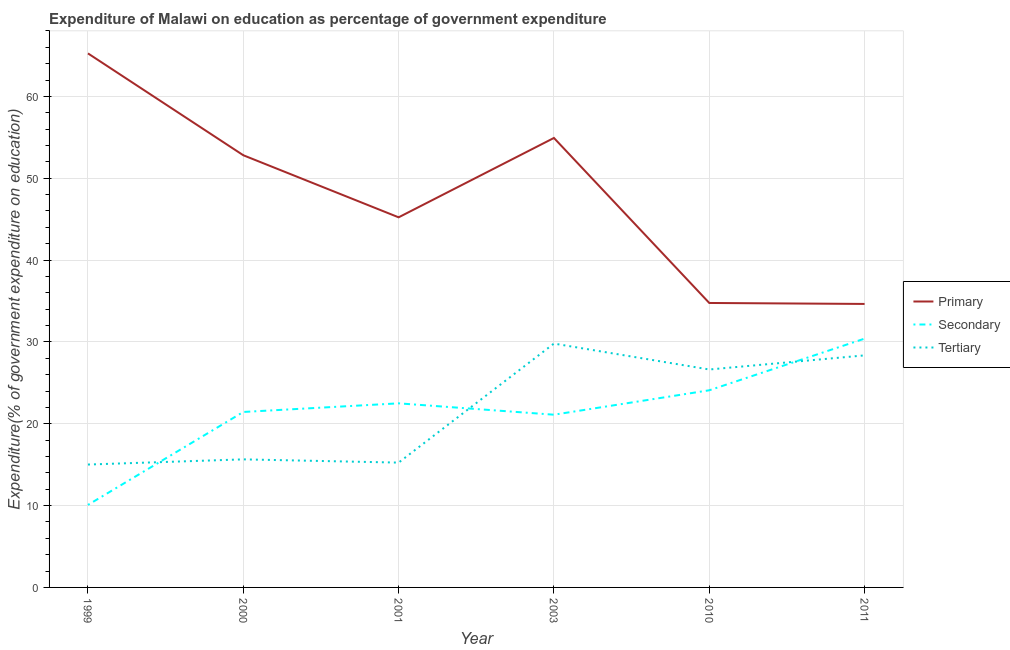Is the number of lines equal to the number of legend labels?
Your answer should be compact. Yes. What is the expenditure on tertiary education in 2000?
Offer a very short reply. 15.65. Across all years, what is the maximum expenditure on primary education?
Provide a short and direct response. 65.26. Across all years, what is the minimum expenditure on secondary education?
Provide a short and direct response. 10.08. In which year was the expenditure on secondary education maximum?
Your answer should be compact. 2011. What is the total expenditure on primary education in the graph?
Your answer should be compact. 287.62. What is the difference between the expenditure on tertiary education in 2000 and that in 2003?
Your answer should be very brief. -14.15. What is the difference between the expenditure on tertiary education in 2011 and the expenditure on secondary education in 2000?
Offer a very short reply. 6.92. What is the average expenditure on secondary education per year?
Provide a succinct answer. 21.6. In the year 2003, what is the difference between the expenditure on tertiary education and expenditure on primary education?
Make the answer very short. -25.13. What is the ratio of the expenditure on secondary education in 2010 to that in 2011?
Give a very brief answer. 0.79. Is the expenditure on tertiary education in 1999 less than that in 2001?
Provide a succinct answer. Yes. What is the difference between the highest and the second highest expenditure on tertiary education?
Your answer should be very brief. 1.44. What is the difference between the highest and the lowest expenditure on secondary education?
Offer a very short reply. 20.32. In how many years, is the expenditure on tertiary education greater than the average expenditure on tertiary education taken over all years?
Your response must be concise. 3. Is the sum of the expenditure on primary education in 2001 and 2010 greater than the maximum expenditure on tertiary education across all years?
Make the answer very short. Yes. Is the expenditure on primary education strictly greater than the expenditure on tertiary education over the years?
Offer a very short reply. Yes. Is the expenditure on secondary education strictly less than the expenditure on primary education over the years?
Your answer should be very brief. Yes. How many lines are there?
Give a very brief answer. 3. How many years are there in the graph?
Offer a terse response. 6. Are the values on the major ticks of Y-axis written in scientific E-notation?
Provide a succinct answer. No. Does the graph contain any zero values?
Make the answer very short. No. Does the graph contain grids?
Ensure brevity in your answer.  Yes. Where does the legend appear in the graph?
Make the answer very short. Center right. How many legend labels are there?
Keep it short and to the point. 3. What is the title of the graph?
Provide a succinct answer. Expenditure of Malawi on education as percentage of government expenditure. What is the label or title of the X-axis?
Offer a terse response. Year. What is the label or title of the Y-axis?
Make the answer very short. Expenditure(% of government expenditure on education). What is the Expenditure(% of government expenditure on education) of Primary in 1999?
Your answer should be very brief. 65.26. What is the Expenditure(% of government expenditure on education) of Secondary in 1999?
Provide a short and direct response. 10.08. What is the Expenditure(% of government expenditure on education) in Tertiary in 1999?
Your answer should be very brief. 15.02. What is the Expenditure(% of government expenditure on education) in Primary in 2000?
Offer a very short reply. 52.81. What is the Expenditure(% of government expenditure on education) in Secondary in 2000?
Keep it short and to the point. 21.44. What is the Expenditure(% of government expenditure on education) in Tertiary in 2000?
Keep it short and to the point. 15.65. What is the Expenditure(% of government expenditure on education) in Primary in 2001?
Offer a very short reply. 45.23. What is the Expenditure(% of government expenditure on education) of Secondary in 2001?
Provide a succinct answer. 22.5. What is the Expenditure(% of government expenditure on education) in Tertiary in 2001?
Provide a short and direct response. 15.25. What is the Expenditure(% of government expenditure on education) of Primary in 2003?
Provide a succinct answer. 54.92. What is the Expenditure(% of government expenditure on education) of Secondary in 2003?
Offer a terse response. 21.11. What is the Expenditure(% of government expenditure on education) of Tertiary in 2003?
Make the answer very short. 29.8. What is the Expenditure(% of government expenditure on education) in Primary in 2010?
Keep it short and to the point. 34.76. What is the Expenditure(% of government expenditure on education) of Secondary in 2010?
Offer a very short reply. 24.09. What is the Expenditure(% of government expenditure on education) in Tertiary in 2010?
Provide a succinct answer. 26.63. What is the Expenditure(% of government expenditure on education) in Primary in 2011?
Your answer should be very brief. 34.64. What is the Expenditure(% of government expenditure on education) in Secondary in 2011?
Offer a terse response. 30.4. What is the Expenditure(% of government expenditure on education) in Tertiary in 2011?
Your answer should be very brief. 28.36. Across all years, what is the maximum Expenditure(% of government expenditure on education) in Primary?
Offer a terse response. 65.26. Across all years, what is the maximum Expenditure(% of government expenditure on education) of Secondary?
Your response must be concise. 30.4. Across all years, what is the maximum Expenditure(% of government expenditure on education) of Tertiary?
Keep it short and to the point. 29.8. Across all years, what is the minimum Expenditure(% of government expenditure on education) in Primary?
Provide a succinct answer. 34.64. Across all years, what is the minimum Expenditure(% of government expenditure on education) in Secondary?
Offer a very short reply. 10.08. Across all years, what is the minimum Expenditure(% of government expenditure on education) in Tertiary?
Your response must be concise. 15.02. What is the total Expenditure(% of government expenditure on education) in Primary in the graph?
Your answer should be very brief. 287.62. What is the total Expenditure(% of government expenditure on education) in Secondary in the graph?
Your answer should be very brief. 129.62. What is the total Expenditure(% of government expenditure on education) in Tertiary in the graph?
Provide a short and direct response. 130.7. What is the difference between the Expenditure(% of government expenditure on education) of Primary in 1999 and that in 2000?
Offer a very short reply. 12.44. What is the difference between the Expenditure(% of government expenditure on education) of Secondary in 1999 and that in 2000?
Your answer should be compact. -11.36. What is the difference between the Expenditure(% of government expenditure on education) in Tertiary in 1999 and that in 2000?
Provide a succinct answer. -0.63. What is the difference between the Expenditure(% of government expenditure on education) in Primary in 1999 and that in 2001?
Offer a very short reply. 20.03. What is the difference between the Expenditure(% of government expenditure on education) in Secondary in 1999 and that in 2001?
Provide a short and direct response. -12.41. What is the difference between the Expenditure(% of government expenditure on education) in Tertiary in 1999 and that in 2001?
Keep it short and to the point. -0.24. What is the difference between the Expenditure(% of government expenditure on education) in Primary in 1999 and that in 2003?
Ensure brevity in your answer.  10.33. What is the difference between the Expenditure(% of government expenditure on education) of Secondary in 1999 and that in 2003?
Provide a short and direct response. -11.02. What is the difference between the Expenditure(% of government expenditure on education) of Tertiary in 1999 and that in 2003?
Make the answer very short. -14.78. What is the difference between the Expenditure(% of government expenditure on education) of Primary in 1999 and that in 2010?
Your answer should be compact. 30.5. What is the difference between the Expenditure(% of government expenditure on education) of Secondary in 1999 and that in 2010?
Offer a very short reply. -14.01. What is the difference between the Expenditure(% of government expenditure on education) in Tertiary in 1999 and that in 2010?
Provide a short and direct response. -11.61. What is the difference between the Expenditure(% of government expenditure on education) in Primary in 1999 and that in 2011?
Your answer should be very brief. 30.61. What is the difference between the Expenditure(% of government expenditure on education) of Secondary in 1999 and that in 2011?
Ensure brevity in your answer.  -20.32. What is the difference between the Expenditure(% of government expenditure on education) in Tertiary in 1999 and that in 2011?
Give a very brief answer. -13.34. What is the difference between the Expenditure(% of government expenditure on education) of Primary in 2000 and that in 2001?
Offer a terse response. 7.59. What is the difference between the Expenditure(% of government expenditure on education) in Secondary in 2000 and that in 2001?
Your answer should be compact. -1.05. What is the difference between the Expenditure(% of government expenditure on education) of Tertiary in 2000 and that in 2001?
Give a very brief answer. 0.4. What is the difference between the Expenditure(% of government expenditure on education) in Primary in 2000 and that in 2003?
Offer a very short reply. -2.11. What is the difference between the Expenditure(% of government expenditure on education) of Secondary in 2000 and that in 2003?
Make the answer very short. 0.33. What is the difference between the Expenditure(% of government expenditure on education) of Tertiary in 2000 and that in 2003?
Make the answer very short. -14.15. What is the difference between the Expenditure(% of government expenditure on education) in Primary in 2000 and that in 2010?
Give a very brief answer. 18.05. What is the difference between the Expenditure(% of government expenditure on education) in Secondary in 2000 and that in 2010?
Ensure brevity in your answer.  -2.65. What is the difference between the Expenditure(% of government expenditure on education) in Tertiary in 2000 and that in 2010?
Offer a terse response. -10.98. What is the difference between the Expenditure(% of government expenditure on education) of Primary in 2000 and that in 2011?
Keep it short and to the point. 18.17. What is the difference between the Expenditure(% of government expenditure on education) of Secondary in 2000 and that in 2011?
Your answer should be very brief. -8.96. What is the difference between the Expenditure(% of government expenditure on education) in Tertiary in 2000 and that in 2011?
Offer a very short reply. -12.71. What is the difference between the Expenditure(% of government expenditure on education) of Primary in 2001 and that in 2003?
Give a very brief answer. -9.7. What is the difference between the Expenditure(% of government expenditure on education) of Secondary in 2001 and that in 2003?
Make the answer very short. 1.39. What is the difference between the Expenditure(% of government expenditure on education) of Tertiary in 2001 and that in 2003?
Your answer should be compact. -14.55. What is the difference between the Expenditure(% of government expenditure on education) of Primary in 2001 and that in 2010?
Offer a very short reply. 10.46. What is the difference between the Expenditure(% of government expenditure on education) of Secondary in 2001 and that in 2010?
Your answer should be very brief. -1.59. What is the difference between the Expenditure(% of government expenditure on education) in Tertiary in 2001 and that in 2010?
Ensure brevity in your answer.  -11.38. What is the difference between the Expenditure(% of government expenditure on education) in Primary in 2001 and that in 2011?
Provide a succinct answer. 10.58. What is the difference between the Expenditure(% of government expenditure on education) of Secondary in 2001 and that in 2011?
Your answer should be very brief. -7.91. What is the difference between the Expenditure(% of government expenditure on education) of Tertiary in 2001 and that in 2011?
Ensure brevity in your answer.  -13.1. What is the difference between the Expenditure(% of government expenditure on education) in Primary in 2003 and that in 2010?
Your answer should be compact. 20.16. What is the difference between the Expenditure(% of government expenditure on education) of Secondary in 2003 and that in 2010?
Your response must be concise. -2.98. What is the difference between the Expenditure(% of government expenditure on education) in Tertiary in 2003 and that in 2010?
Offer a very short reply. 3.17. What is the difference between the Expenditure(% of government expenditure on education) in Primary in 2003 and that in 2011?
Make the answer very short. 20.28. What is the difference between the Expenditure(% of government expenditure on education) in Secondary in 2003 and that in 2011?
Give a very brief answer. -9.3. What is the difference between the Expenditure(% of government expenditure on education) in Tertiary in 2003 and that in 2011?
Provide a succinct answer. 1.44. What is the difference between the Expenditure(% of government expenditure on education) in Primary in 2010 and that in 2011?
Your answer should be very brief. 0.12. What is the difference between the Expenditure(% of government expenditure on education) in Secondary in 2010 and that in 2011?
Your response must be concise. -6.31. What is the difference between the Expenditure(% of government expenditure on education) in Tertiary in 2010 and that in 2011?
Ensure brevity in your answer.  -1.73. What is the difference between the Expenditure(% of government expenditure on education) in Primary in 1999 and the Expenditure(% of government expenditure on education) in Secondary in 2000?
Make the answer very short. 43.82. What is the difference between the Expenditure(% of government expenditure on education) of Primary in 1999 and the Expenditure(% of government expenditure on education) of Tertiary in 2000?
Make the answer very short. 49.61. What is the difference between the Expenditure(% of government expenditure on education) of Secondary in 1999 and the Expenditure(% of government expenditure on education) of Tertiary in 2000?
Give a very brief answer. -5.56. What is the difference between the Expenditure(% of government expenditure on education) of Primary in 1999 and the Expenditure(% of government expenditure on education) of Secondary in 2001?
Offer a terse response. 42.76. What is the difference between the Expenditure(% of government expenditure on education) in Primary in 1999 and the Expenditure(% of government expenditure on education) in Tertiary in 2001?
Keep it short and to the point. 50. What is the difference between the Expenditure(% of government expenditure on education) in Secondary in 1999 and the Expenditure(% of government expenditure on education) in Tertiary in 2001?
Your response must be concise. -5.17. What is the difference between the Expenditure(% of government expenditure on education) of Primary in 1999 and the Expenditure(% of government expenditure on education) of Secondary in 2003?
Keep it short and to the point. 44.15. What is the difference between the Expenditure(% of government expenditure on education) in Primary in 1999 and the Expenditure(% of government expenditure on education) in Tertiary in 2003?
Give a very brief answer. 35.46. What is the difference between the Expenditure(% of government expenditure on education) in Secondary in 1999 and the Expenditure(% of government expenditure on education) in Tertiary in 2003?
Your response must be concise. -19.71. What is the difference between the Expenditure(% of government expenditure on education) in Primary in 1999 and the Expenditure(% of government expenditure on education) in Secondary in 2010?
Make the answer very short. 41.17. What is the difference between the Expenditure(% of government expenditure on education) in Primary in 1999 and the Expenditure(% of government expenditure on education) in Tertiary in 2010?
Give a very brief answer. 38.63. What is the difference between the Expenditure(% of government expenditure on education) of Secondary in 1999 and the Expenditure(% of government expenditure on education) of Tertiary in 2010?
Provide a short and direct response. -16.55. What is the difference between the Expenditure(% of government expenditure on education) of Primary in 1999 and the Expenditure(% of government expenditure on education) of Secondary in 2011?
Provide a short and direct response. 34.85. What is the difference between the Expenditure(% of government expenditure on education) of Primary in 1999 and the Expenditure(% of government expenditure on education) of Tertiary in 2011?
Make the answer very short. 36.9. What is the difference between the Expenditure(% of government expenditure on education) of Secondary in 1999 and the Expenditure(% of government expenditure on education) of Tertiary in 2011?
Keep it short and to the point. -18.27. What is the difference between the Expenditure(% of government expenditure on education) in Primary in 2000 and the Expenditure(% of government expenditure on education) in Secondary in 2001?
Provide a short and direct response. 30.32. What is the difference between the Expenditure(% of government expenditure on education) in Primary in 2000 and the Expenditure(% of government expenditure on education) in Tertiary in 2001?
Provide a short and direct response. 37.56. What is the difference between the Expenditure(% of government expenditure on education) in Secondary in 2000 and the Expenditure(% of government expenditure on education) in Tertiary in 2001?
Provide a succinct answer. 6.19. What is the difference between the Expenditure(% of government expenditure on education) of Primary in 2000 and the Expenditure(% of government expenditure on education) of Secondary in 2003?
Your answer should be very brief. 31.7. What is the difference between the Expenditure(% of government expenditure on education) of Primary in 2000 and the Expenditure(% of government expenditure on education) of Tertiary in 2003?
Make the answer very short. 23.01. What is the difference between the Expenditure(% of government expenditure on education) in Secondary in 2000 and the Expenditure(% of government expenditure on education) in Tertiary in 2003?
Make the answer very short. -8.36. What is the difference between the Expenditure(% of government expenditure on education) of Primary in 2000 and the Expenditure(% of government expenditure on education) of Secondary in 2010?
Make the answer very short. 28.72. What is the difference between the Expenditure(% of government expenditure on education) of Primary in 2000 and the Expenditure(% of government expenditure on education) of Tertiary in 2010?
Provide a short and direct response. 26.18. What is the difference between the Expenditure(% of government expenditure on education) of Secondary in 2000 and the Expenditure(% of government expenditure on education) of Tertiary in 2010?
Make the answer very short. -5.19. What is the difference between the Expenditure(% of government expenditure on education) in Primary in 2000 and the Expenditure(% of government expenditure on education) in Secondary in 2011?
Ensure brevity in your answer.  22.41. What is the difference between the Expenditure(% of government expenditure on education) in Primary in 2000 and the Expenditure(% of government expenditure on education) in Tertiary in 2011?
Make the answer very short. 24.46. What is the difference between the Expenditure(% of government expenditure on education) of Secondary in 2000 and the Expenditure(% of government expenditure on education) of Tertiary in 2011?
Provide a succinct answer. -6.92. What is the difference between the Expenditure(% of government expenditure on education) in Primary in 2001 and the Expenditure(% of government expenditure on education) in Secondary in 2003?
Give a very brief answer. 24.12. What is the difference between the Expenditure(% of government expenditure on education) in Primary in 2001 and the Expenditure(% of government expenditure on education) in Tertiary in 2003?
Offer a terse response. 15.43. What is the difference between the Expenditure(% of government expenditure on education) in Secondary in 2001 and the Expenditure(% of government expenditure on education) in Tertiary in 2003?
Offer a terse response. -7.3. What is the difference between the Expenditure(% of government expenditure on education) in Primary in 2001 and the Expenditure(% of government expenditure on education) in Secondary in 2010?
Your answer should be compact. 21.14. What is the difference between the Expenditure(% of government expenditure on education) in Primary in 2001 and the Expenditure(% of government expenditure on education) in Tertiary in 2010?
Offer a very short reply. 18.6. What is the difference between the Expenditure(% of government expenditure on education) in Secondary in 2001 and the Expenditure(% of government expenditure on education) in Tertiary in 2010?
Your answer should be very brief. -4.14. What is the difference between the Expenditure(% of government expenditure on education) of Primary in 2001 and the Expenditure(% of government expenditure on education) of Secondary in 2011?
Your response must be concise. 14.82. What is the difference between the Expenditure(% of government expenditure on education) in Primary in 2001 and the Expenditure(% of government expenditure on education) in Tertiary in 2011?
Provide a short and direct response. 16.87. What is the difference between the Expenditure(% of government expenditure on education) of Secondary in 2001 and the Expenditure(% of government expenditure on education) of Tertiary in 2011?
Keep it short and to the point. -5.86. What is the difference between the Expenditure(% of government expenditure on education) in Primary in 2003 and the Expenditure(% of government expenditure on education) in Secondary in 2010?
Your answer should be very brief. 30.83. What is the difference between the Expenditure(% of government expenditure on education) in Primary in 2003 and the Expenditure(% of government expenditure on education) in Tertiary in 2010?
Your response must be concise. 28.29. What is the difference between the Expenditure(% of government expenditure on education) of Secondary in 2003 and the Expenditure(% of government expenditure on education) of Tertiary in 2010?
Offer a very short reply. -5.52. What is the difference between the Expenditure(% of government expenditure on education) in Primary in 2003 and the Expenditure(% of government expenditure on education) in Secondary in 2011?
Your response must be concise. 24.52. What is the difference between the Expenditure(% of government expenditure on education) of Primary in 2003 and the Expenditure(% of government expenditure on education) of Tertiary in 2011?
Your answer should be compact. 26.57. What is the difference between the Expenditure(% of government expenditure on education) in Secondary in 2003 and the Expenditure(% of government expenditure on education) in Tertiary in 2011?
Your answer should be compact. -7.25. What is the difference between the Expenditure(% of government expenditure on education) in Primary in 2010 and the Expenditure(% of government expenditure on education) in Secondary in 2011?
Your answer should be compact. 4.36. What is the difference between the Expenditure(% of government expenditure on education) of Primary in 2010 and the Expenditure(% of government expenditure on education) of Tertiary in 2011?
Keep it short and to the point. 6.4. What is the difference between the Expenditure(% of government expenditure on education) in Secondary in 2010 and the Expenditure(% of government expenditure on education) in Tertiary in 2011?
Your response must be concise. -4.27. What is the average Expenditure(% of government expenditure on education) of Primary per year?
Offer a very short reply. 47.94. What is the average Expenditure(% of government expenditure on education) of Secondary per year?
Your response must be concise. 21.6. What is the average Expenditure(% of government expenditure on education) in Tertiary per year?
Make the answer very short. 21.78. In the year 1999, what is the difference between the Expenditure(% of government expenditure on education) in Primary and Expenditure(% of government expenditure on education) in Secondary?
Your answer should be compact. 55.17. In the year 1999, what is the difference between the Expenditure(% of government expenditure on education) in Primary and Expenditure(% of government expenditure on education) in Tertiary?
Offer a terse response. 50.24. In the year 1999, what is the difference between the Expenditure(% of government expenditure on education) of Secondary and Expenditure(% of government expenditure on education) of Tertiary?
Offer a terse response. -4.93. In the year 2000, what is the difference between the Expenditure(% of government expenditure on education) of Primary and Expenditure(% of government expenditure on education) of Secondary?
Ensure brevity in your answer.  31.37. In the year 2000, what is the difference between the Expenditure(% of government expenditure on education) in Primary and Expenditure(% of government expenditure on education) in Tertiary?
Provide a succinct answer. 37.16. In the year 2000, what is the difference between the Expenditure(% of government expenditure on education) in Secondary and Expenditure(% of government expenditure on education) in Tertiary?
Provide a succinct answer. 5.79. In the year 2001, what is the difference between the Expenditure(% of government expenditure on education) of Primary and Expenditure(% of government expenditure on education) of Secondary?
Offer a terse response. 22.73. In the year 2001, what is the difference between the Expenditure(% of government expenditure on education) of Primary and Expenditure(% of government expenditure on education) of Tertiary?
Make the answer very short. 29.97. In the year 2001, what is the difference between the Expenditure(% of government expenditure on education) of Secondary and Expenditure(% of government expenditure on education) of Tertiary?
Offer a very short reply. 7.24. In the year 2003, what is the difference between the Expenditure(% of government expenditure on education) of Primary and Expenditure(% of government expenditure on education) of Secondary?
Provide a succinct answer. 33.82. In the year 2003, what is the difference between the Expenditure(% of government expenditure on education) of Primary and Expenditure(% of government expenditure on education) of Tertiary?
Ensure brevity in your answer.  25.13. In the year 2003, what is the difference between the Expenditure(% of government expenditure on education) in Secondary and Expenditure(% of government expenditure on education) in Tertiary?
Offer a very short reply. -8.69. In the year 2010, what is the difference between the Expenditure(% of government expenditure on education) in Primary and Expenditure(% of government expenditure on education) in Secondary?
Your answer should be compact. 10.67. In the year 2010, what is the difference between the Expenditure(% of government expenditure on education) in Primary and Expenditure(% of government expenditure on education) in Tertiary?
Provide a short and direct response. 8.13. In the year 2010, what is the difference between the Expenditure(% of government expenditure on education) in Secondary and Expenditure(% of government expenditure on education) in Tertiary?
Your answer should be compact. -2.54. In the year 2011, what is the difference between the Expenditure(% of government expenditure on education) of Primary and Expenditure(% of government expenditure on education) of Secondary?
Your response must be concise. 4.24. In the year 2011, what is the difference between the Expenditure(% of government expenditure on education) of Primary and Expenditure(% of government expenditure on education) of Tertiary?
Give a very brief answer. 6.29. In the year 2011, what is the difference between the Expenditure(% of government expenditure on education) in Secondary and Expenditure(% of government expenditure on education) in Tertiary?
Your response must be concise. 2.05. What is the ratio of the Expenditure(% of government expenditure on education) in Primary in 1999 to that in 2000?
Keep it short and to the point. 1.24. What is the ratio of the Expenditure(% of government expenditure on education) of Secondary in 1999 to that in 2000?
Your answer should be compact. 0.47. What is the ratio of the Expenditure(% of government expenditure on education) of Tertiary in 1999 to that in 2000?
Your answer should be compact. 0.96. What is the ratio of the Expenditure(% of government expenditure on education) of Primary in 1999 to that in 2001?
Your answer should be very brief. 1.44. What is the ratio of the Expenditure(% of government expenditure on education) in Secondary in 1999 to that in 2001?
Ensure brevity in your answer.  0.45. What is the ratio of the Expenditure(% of government expenditure on education) in Tertiary in 1999 to that in 2001?
Offer a terse response. 0.98. What is the ratio of the Expenditure(% of government expenditure on education) in Primary in 1999 to that in 2003?
Ensure brevity in your answer.  1.19. What is the ratio of the Expenditure(% of government expenditure on education) in Secondary in 1999 to that in 2003?
Keep it short and to the point. 0.48. What is the ratio of the Expenditure(% of government expenditure on education) in Tertiary in 1999 to that in 2003?
Make the answer very short. 0.5. What is the ratio of the Expenditure(% of government expenditure on education) in Primary in 1999 to that in 2010?
Give a very brief answer. 1.88. What is the ratio of the Expenditure(% of government expenditure on education) of Secondary in 1999 to that in 2010?
Give a very brief answer. 0.42. What is the ratio of the Expenditure(% of government expenditure on education) of Tertiary in 1999 to that in 2010?
Provide a short and direct response. 0.56. What is the ratio of the Expenditure(% of government expenditure on education) in Primary in 1999 to that in 2011?
Offer a terse response. 1.88. What is the ratio of the Expenditure(% of government expenditure on education) in Secondary in 1999 to that in 2011?
Offer a very short reply. 0.33. What is the ratio of the Expenditure(% of government expenditure on education) in Tertiary in 1999 to that in 2011?
Provide a succinct answer. 0.53. What is the ratio of the Expenditure(% of government expenditure on education) of Primary in 2000 to that in 2001?
Give a very brief answer. 1.17. What is the ratio of the Expenditure(% of government expenditure on education) in Secondary in 2000 to that in 2001?
Provide a short and direct response. 0.95. What is the ratio of the Expenditure(% of government expenditure on education) of Tertiary in 2000 to that in 2001?
Make the answer very short. 1.03. What is the ratio of the Expenditure(% of government expenditure on education) in Primary in 2000 to that in 2003?
Provide a succinct answer. 0.96. What is the ratio of the Expenditure(% of government expenditure on education) in Secondary in 2000 to that in 2003?
Your response must be concise. 1.02. What is the ratio of the Expenditure(% of government expenditure on education) of Tertiary in 2000 to that in 2003?
Your answer should be very brief. 0.53. What is the ratio of the Expenditure(% of government expenditure on education) in Primary in 2000 to that in 2010?
Keep it short and to the point. 1.52. What is the ratio of the Expenditure(% of government expenditure on education) in Secondary in 2000 to that in 2010?
Ensure brevity in your answer.  0.89. What is the ratio of the Expenditure(% of government expenditure on education) in Tertiary in 2000 to that in 2010?
Provide a succinct answer. 0.59. What is the ratio of the Expenditure(% of government expenditure on education) of Primary in 2000 to that in 2011?
Provide a succinct answer. 1.52. What is the ratio of the Expenditure(% of government expenditure on education) in Secondary in 2000 to that in 2011?
Keep it short and to the point. 0.71. What is the ratio of the Expenditure(% of government expenditure on education) in Tertiary in 2000 to that in 2011?
Offer a terse response. 0.55. What is the ratio of the Expenditure(% of government expenditure on education) of Primary in 2001 to that in 2003?
Your answer should be very brief. 0.82. What is the ratio of the Expenditure(% of government expenditure on education) in Secondary in 2001 to that in 2003?
Offer a very short reply. 1.07. What is the ratio of the Expenditure(% of government expenditure on education) of Tertiary in 2001 to that in 2003?
Your response must be concise. 0.51. What is the ratio of the Expenditure(% of government expenditure on education) of Primary in 2001 to that in 2010?
Offer a terse response. 1.3. What is the ratio of the Expenditure(% of government expenditure on education) of Secondary in 2001 to that in 2010?
Give a very brief answer. 0.93. What is the ratio of the Expenditure(% of government expenditure on education) of Tertiary in 2001 to that in 2010?
Your answer should be compact. 0.57. What is the ratio of the Expenditure(% of government expenditure on education) in Primary in 2001 to that in 2011?
Offer a terse response. 1.31. What is the ratio of the Expenditure(% of government expenditure on education) of Secondary in 2001 to that in 2011?
Your response must be concise. 0.74. What is the ratio of the Expenditure(% of government expenditure on education) of Tertiary in 2001 to that in 2011?
Offer a very short reply. 0.54. What is the ratio of the Expenditure(% of government expenditure on education) of Primary in 2003 to that in 2010?
Provide a short and direct response. 1.58. What is the ratio of the Expenditure(% of government expenditure on education) of Secondary in 2003 to that in 2010?
Keep it short and to the point. 0.88. What is the ratio of the Expenditure(% of government expenditure on education) of Tertiary in 2003 to that in 2010?
Keep it short and to the point. 1.12. What is the ratio of the Expenditure(% of government expenditure on education) of Primary in 2003 to that in 2011?
Provide a short and direct response. 1.59. What is the ratio of the Expenditure(% of government expenditure on education) of Secondary in 2003 to that in 2011?
Make the answer very short. 0.69. What is the ratio of the Expenditure(% of government expenditure on education) of Tertiary in 2003 to that in 2011?
Keep it short and to the point. 1.05. What is the ratio of the Expenditure(% of government expenditure on education) of Primary in 2010 to that in 2011?
Ensure brevity in your answer.  1. What is the ratio of the Expenditure(% of government expenditure on education) of Secondary in 2010 to that in 2011?
Give a very brief answer. 0.79. What is the ratio of the Expenditure(% of government expenditure on education) of Tertiary in 2010 to that in 2011?
Make the answer very short. 0.94. What is the difference between the highest and the second highest Expenditure(% of government expenditure on education) in Primary?
Your answer should be very brief. 10.33. What is the difference between the highest and the second highest Expenditure(% of government expenditure on education) of Secondary?
Your answer should be very brief. 6.31. What is the difference between the highest and the second highest Expenditure(% of government expenditure on education) in Tertiary?
Provide a short and direct response. 1.44. What is the difference between the highest and the lowest Expenditure(% of government expenditure on education) of Primary?
Ensure brevity in your answer.  30.61. What is the difference between the highest and the lowest Expenditure(% of government expenditure on education) in Secondary?
Make the answer very short. 20.32. What is the difference between the highest and the lowest Expenditure(% of government expenditure on education) in Tertiary?
Provide a succinct answer. 14.78. 